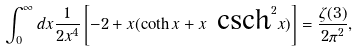Convert formula to latex. <formula><loc_0><loc_0><loc_500><loc_500>\int _ { 0 } ^ { \infty } d x \frac { 1 } { 2 x ^ { 4 } } \left [ - 2 + x ( \coth x + x \text {   csch} ^ { 2 } x ) \right ] = \frac { \zeta ( 3 ) } { 2 \pi ^ { 2 } } ,</formula> 